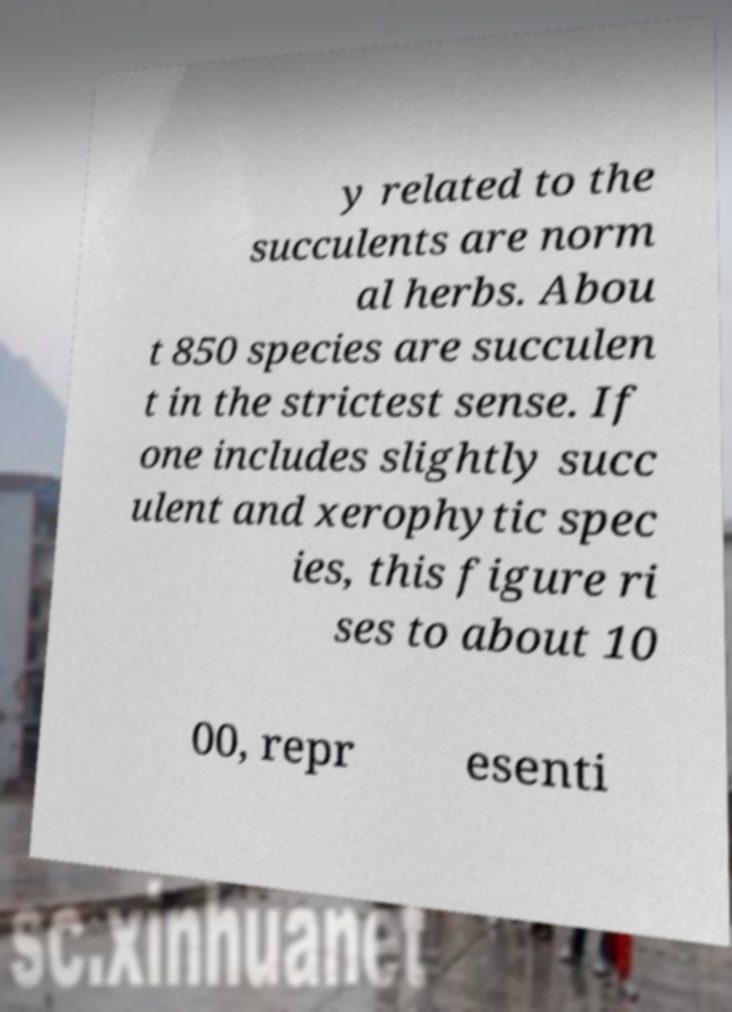Could you assist in decoding the text presented in this image and type it out clearly? y related to the succulents are norm al herbs. Abou t 850 species are succulen t in the strictest sense. If one includes slightly succ ulent and xerophytic spec ies, this figure ri ses to about 10 00, repr esenti 